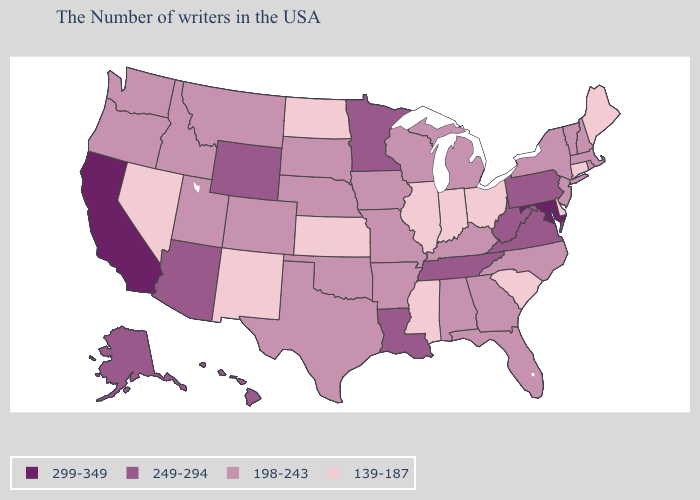Among the states that border Mississippi , does Arkansas have the lowest value?
Be succinct. Yes. What is the value of Alabama?
Quick response, please. 198-243. What is the highest value in the USA?
Be succinct. 299-349. What is the value of Washington?
Short answer required. 198-243. What is the value of Connecticut?
Concise answer only. 139-187. Name the states that have a value in the range 249-294?
Be succinct. Pennsylvania, Virginia, West Virginia, Tennessee, Louisiana, Minnesota, Wyoming, Arizona, Alaska, Hawaii. What is the value of Virginia?
Give a very brief answer. 249-294. What is the value of New Mexico?
Quick response, please. 139-187. Name the states that have a value in the range 249-294?
Write a very short answer. Pennsylvania, Virginia, West Virginia, Tennessee, Louisiana, Minnesota, Wyoming, Arizona, Alaska, Hawaii. What is the lowest value in the USA?
Concise answer only. 139-187. Does Iowa have the lowest value in the MidWest?
Write a very short answer. No. Does Florida have the same value as Missouri?
Keep it brief. Yes. Name the states that have a value in the range 299-349?
Short answer required. Maryland, California. Does the map have missing data?
Quick response, please. No. What is the value of Indiana?
Write a very short answer. 139-187. 